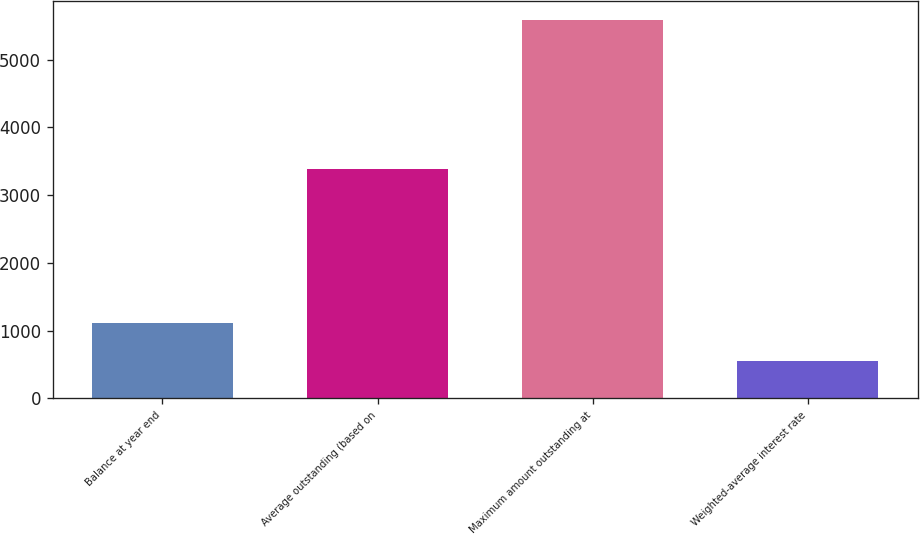Convert chart. <chart><loc_0><loc_0><loc_500><loc_500><bar_chart><fcel>Balance at year end<fcel>Average outstanding (based on<fcel>Maximum amount outstanding at<fcel>Weighted-average interest rate<nl><fcel>1116.68<fcel>3384<fcel>5583<fcel>558.39<nl></chart> 